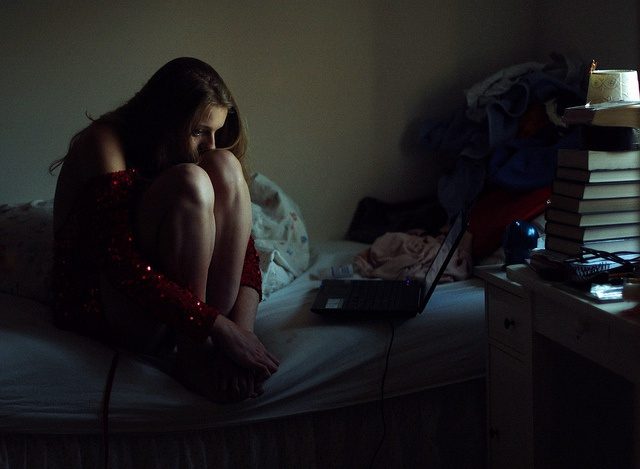Describe the objects in this image and their specific colors. I can see bed in black, teal, blue, and darkblue tones, people in black and gray tones, laptop in black and darkblue tones, book in black and gray tones, and book in black and gray tones in this image. 